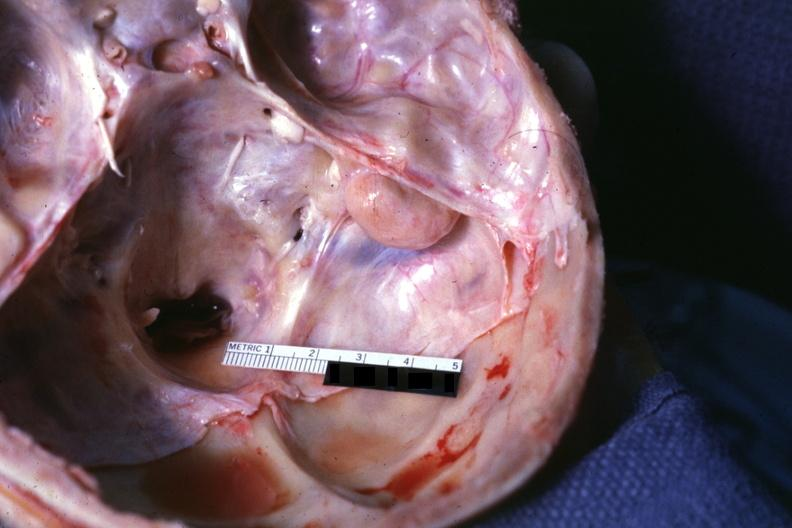what does this image show?
Answer the question using a single word or phrase. Opened base of skull with brain removed 